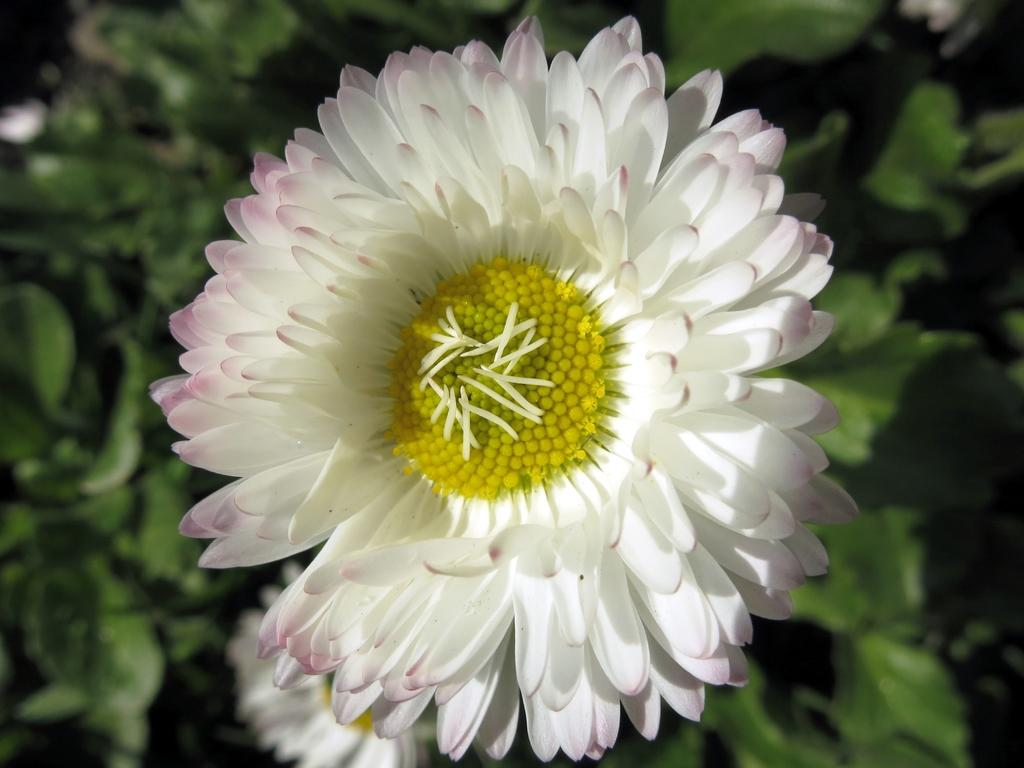What type of living organisms can be seen in the image? There are flowers in the image. What color is the background of the image? The background of the image is green. What type of house is visible in the image? There is no house present in the image; it features flowers and a green background. What emotion can be seen on the flowers in the image? Flowers do not have emotions, so it is not possible to determine any emotion or shame from the image. 